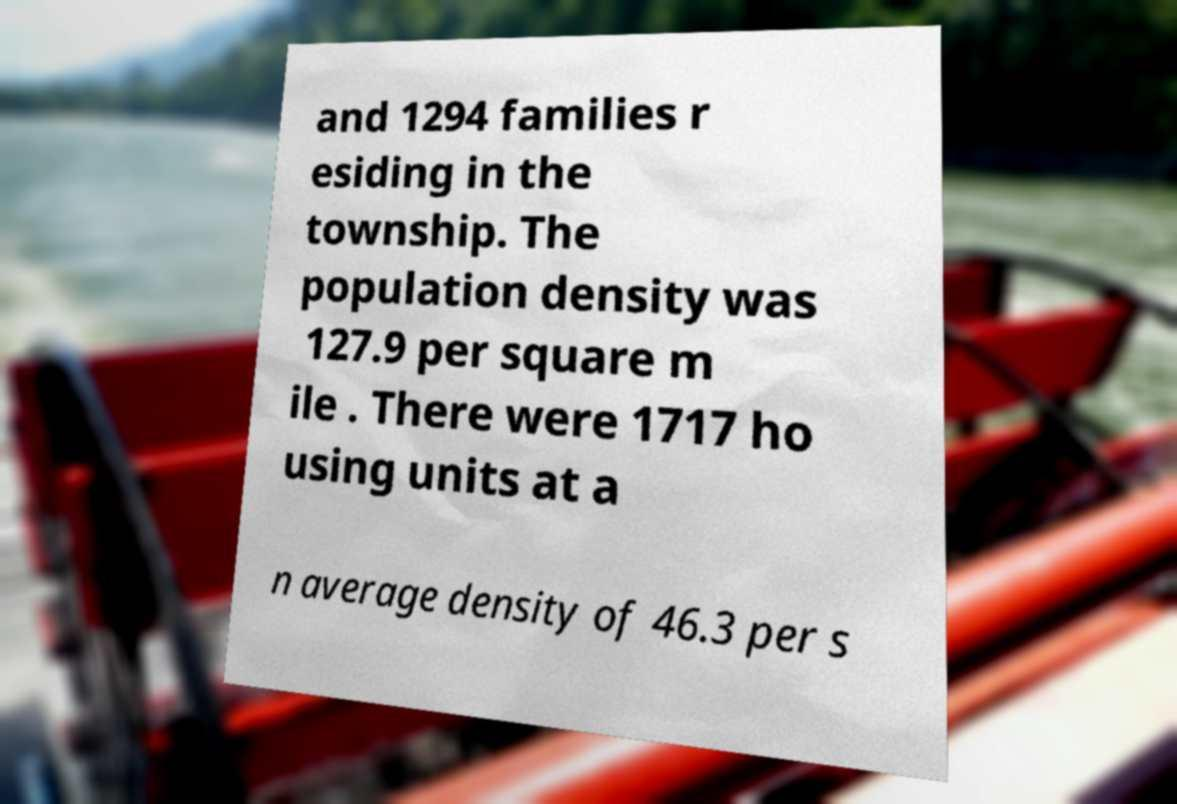Could you extract and type out the text from this image? and 1294 families r esiding in the township. The population density was 127.9 per square m ile . There were 1717 ho using units at a n average density of 46.3 per s 